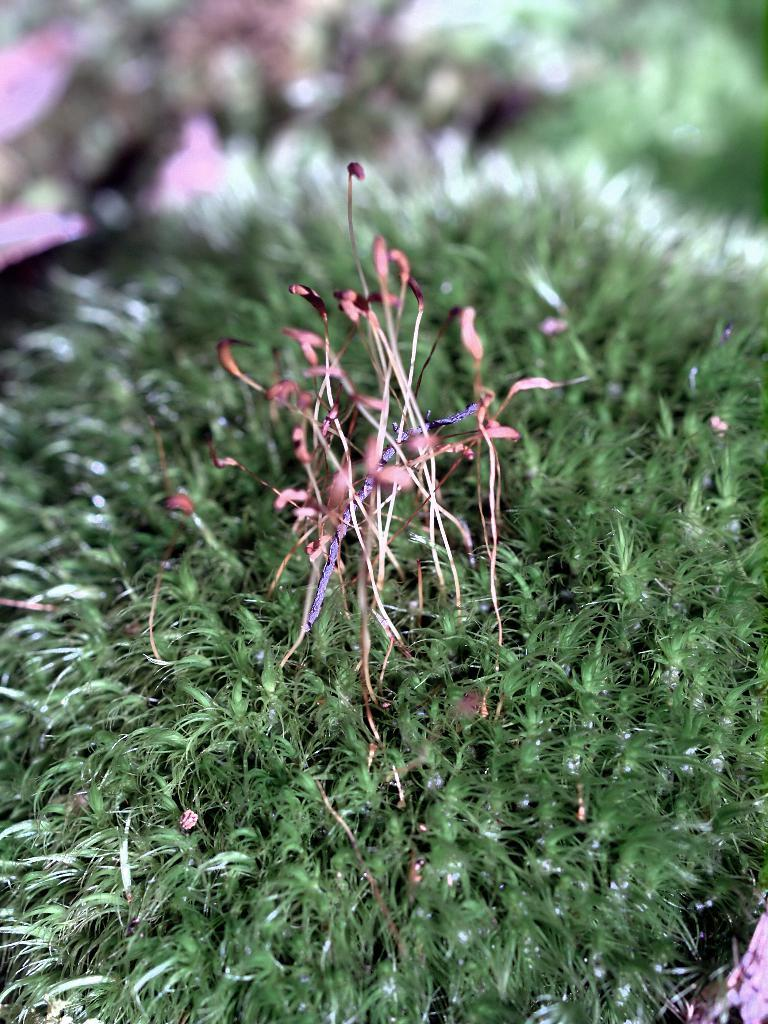What type of living organisms can be seen in the image? Plants can be seen in the image. What time of day is it in the image? The time of day cannot be determined from the image, as there is no information about lighting or shadows to suggest a specific time. 